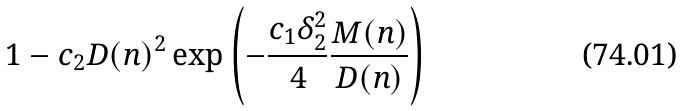<formula> <loc_0><loc_0><loc_500><loc_500>1 - c _ { 2 } D ( n ) ^ { 2 } \exp \left ( - \frac { c _ { 1 } \delta _ { 2 } ^ { 2 } } { 4 } \frac { M ( n ) } { D ( n ) } \right )</formula> 